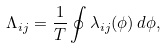<formula> <loc_0><loc_0><loc_500><loc_500>\Lambda _ { i j } = \frac { 1 } { T } \oint \lambda _ { i j } ( \phi ) \, d \phi ,</formula> 